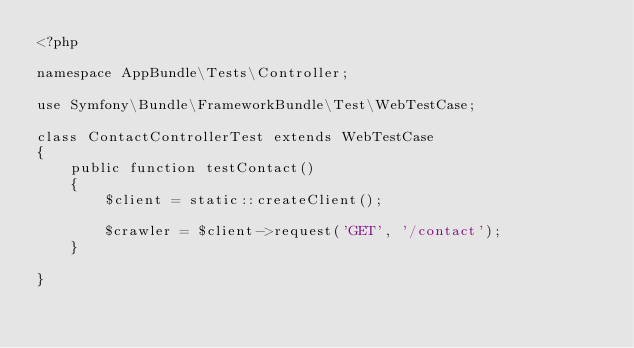Convert code to text. <code><loc_0><loc_0><loc_500><loc_500><_PHP_><?php

namespace AppBundle\Tests\Controller;

use Symfony\Bundle\FrameworkBundle\Test\WebTestCase;

class ContactControllerTest extends WebTestCase
{
    public function testContact()
    {
        $client = static::createClient();

        $crawler = $client->request('GET', '/contact');
    }

}
</code> 